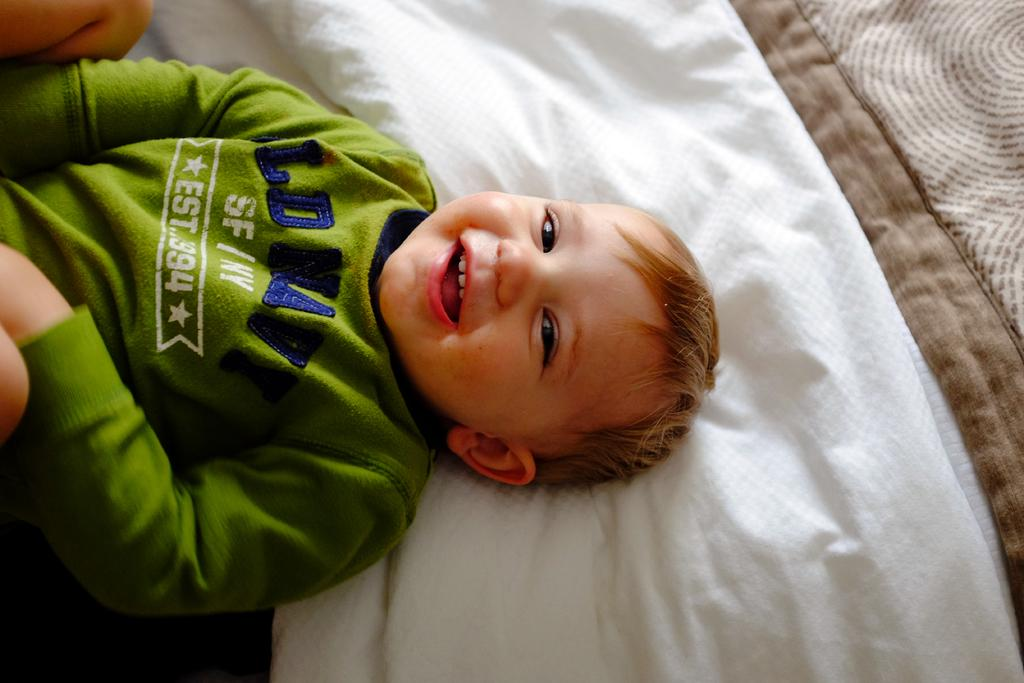What is the main subject of the image? There is a boy in the image. What is the boy doing in the image? The boy is lying on a bed. What type of connection can be seen in the image? There is no connection present in the image; it features a boy lying on a bed. 